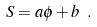<formula> <loc_0><loc_0><loc_500><loc_500>S = a \phi + b \ .</formula> 